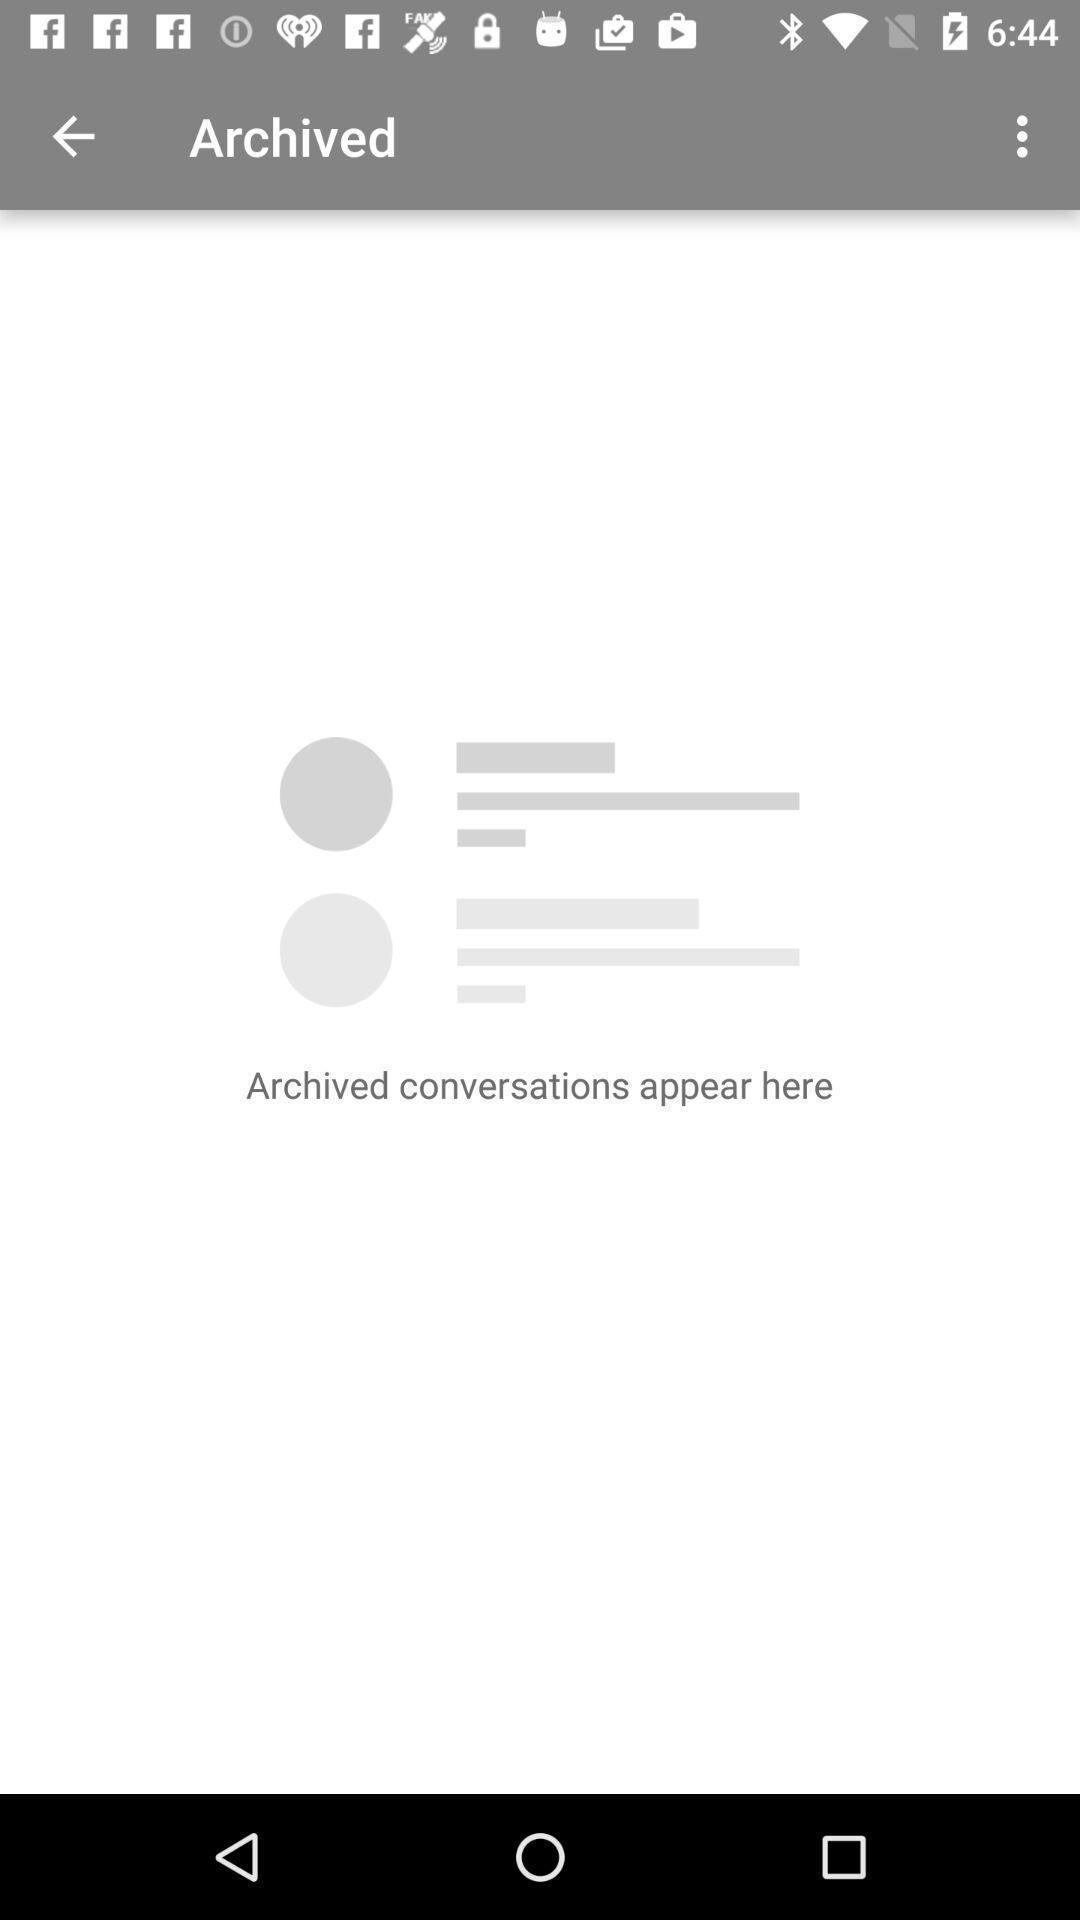Summarize the main components in this picture. Page displaying the empty archived conversation. 